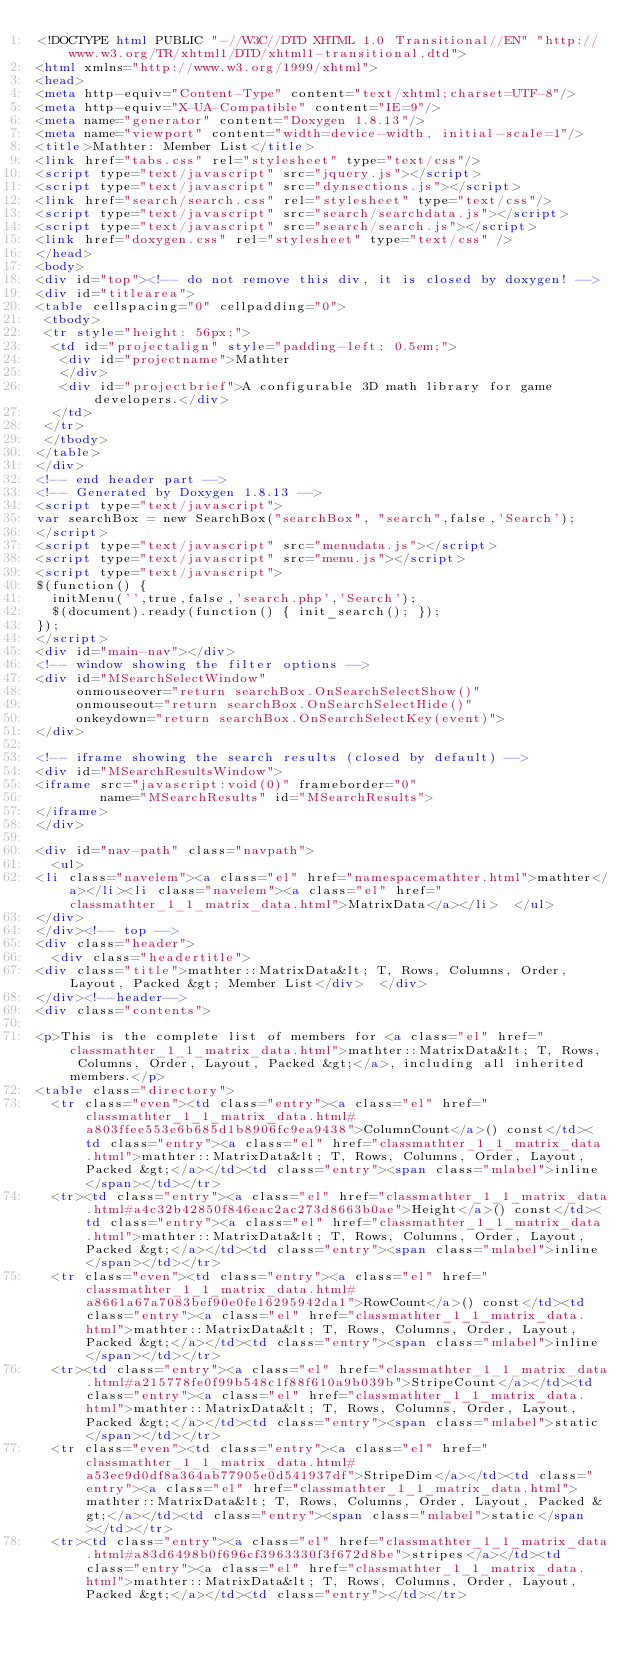<code> <loc_0><loc_0><loc_500><loc_500><_HTML_><!DOCTYPE html PUBLIC "-//W3C//DTD XHTML 1.0 Transitional//EN" "http://www.w3.org/TR/xhtml1/DTD/xhtml1-transitional.dtd">
<html xmlns="http://www.w3.org/1999/xhtml">
<head>
<meta http-equiv="Content-Type" content="text/xhtml;charset=UTF-8"/>
<meta http-equiv="X-UA-Compatible" content="IE=9"/>
<meta name="generator" content="Doxygen 1.8.13"/>
<meta name="viewport" content="width=device-width, initial-scale=1"/>
<title>Mathter: Member List</title>
<link href="tabs.css" rel="stylesheet" type="text/css"/>
<script type="text/javascript" src="jquery.js"></script>
<script type="text/javascript" src="dynsections.js"></script>
<link href="search/search.css" rel="stylesheet" type="text/css"/>
<script type="text/javascript" src="search/searchdata.js"></script>
<script type="text/javascript" src="search/search.js"></script>
<link href="doxygen.css" rel="stylesheet" type="text/css" />
</head>
<body>
<div id="top"><!-- do not remove this div, it is closed by doxygen! -->
<div id="titlearea">
<table cellspacing="0" cellpadding="0">
 <tbody>
 <tr style="height: 56px;">
  <td id="projectalign" style="padding-left: 0.5em;">
   <div id="projectname">Mathter
   </div>
   <div id="projectbrief">A configurable 3D math library for game developers.</div>
  </td>
 </tr>
 </tbody>
</table>
</div>
<!-- end header part -->
<!-- Generated by Doxygen 1.8.13 -->
<script type="text/javascript">
var searchBox = new SearchBox("searchBox", "search",false,'Search');
</script>
<script type="text/javascript" src="menudata.js"></script>
<script type="text/javascript" src="menu.js"></script>
<script type="text/javascript">
$(function() {
  initMenu('',true,false,'search.php','Search');
  $(document).ready(function() { init_search(); });
});
</script>
<div id="main-nav"></div>
<!-- window showing the filter options -->
<div id="MSearchSelectWindow"
     onmouseover="return searchBox.OnSearchSelectShow()"
     onmouseout="return searchBox.OnSearchSelectHide()"
     onkeydown="return searchBox.OnSearchSelectKey(event)">
</div>

<!-- iframe showing the search results (closed by default) -->
<div id="MSearchResultsWindow">
<iframe src="javascript:void(0)" frameborder="0" 
        name="MSearchResults" id="MSearchResults">
</iframe>
</div>

<div id="nav-path" class="navpath">
  <ul>
<li class="navelem"><a class="el" href="namespacemathter.html">mathter</a></li><li class="navelem"><a class="el" href="classmathter_1_1_matrix_data.html">MatrixData</a></li>  </ul>
</div>
</div><!-- top -->
<div class="header">
  <div class="headertitle">
<div class="title">mathter::MatrixData&lt; T, Rows, Columns, Order, Layout, Packed &gt; Member List</div>  </div>
</div><!--header-->
<div class="contents">

<p>This is the complete list of members for <a class="el" href="classmathter_1_1_matrix_data.html">mathter::MatrixData&lt; T, Rows, Columns, Order, Layout, Packed &gt;</a>, including all inherited members.</p>
<table class="directory">
  <tr class="even"><td class="entry"><a class="el" href="classmathter_1_1_matrix_data.html#a803ffee553e6b685d1b8906fc9ea9438">ColumnCount</a>() const</td><td class="entry"><a class="el" href="classmathter_1_1_matrix_data.html">mathter::MatrixData&lt; T, Rows, Columns, Order, Layout, Packed &gt;</a></td><td class="entry"><span class="mlabel">inline</span></td></tr>
  <tr><td class="entry"><a class="el" href="classmathter_1_1_matrix_data.html#a4c32b42850f846eac2ac273d8663b0ae">Height</a>() const</td><td class="entry"><a class="el" href="classmathter_1_1_matrix_data.html">mathter::MatrixData&lt; T, Rows, Columns, Order, Layout, Packed &gt;</a></td><td class="entry"><span class="mlabel">inline</span></td></tr>
  <tr class="even"><td class="entry"><a class="el" href="classmathter_1_1_matrix_data.html#a8661a67a7083bef90e0fe16295942da1">RowCount</a>() const</td><td class="entry"><a class="el" href="classmathter_1_1_matrix_data.html">mathter::MatrixData&lt; T, Rows, Columns, Order, Layout, Packed &gt;</a></td><td class="entry"><span class="mlabel">inline</span></td></tr>
  <tr><td class="entry"><a class="el" href="classmathter_1_1_matrix_data.html#a215778fe0f99b548c1f88f610a9b039b">StripeCount</a></td><td class="entry"><a class="el" href="classmathter_1_1_matrix_data.html">mathter::MatrixData&lt; T, Rows, Columns, Order, Layout, Packed &gt;</a></td><td class="entry"><span class="mlabel">static</span></td></tr>
  <tr class="even"><td class="entry"><a class="el" href="classmathter_1_1_matrix_data.html#a53ec9d0df8a364ab77905e0d541937df">StripeDim</a></td><td class="entry"><a class="el" href="classmathter_1_1_matrix_data.html">mathter::MatrixData&lt; T, Rows, Columns, Order, Layout, Packed &gt;</a></td><td class="entry"><span class="mlabel">static</span></td></tr>
  <tr><td class="entry"><a class="el" href="classmathter_1_1_matrix_data.html#a83d6498b0f696cf3963330f3f672d8be">stripes</a></td><td class="entry"><a class="el" href="classmathter_1_1_matrix_data.html">mathter::MatrixData&lt; T, Rows, Columns, Order, Layout, Packed &gt;</a></td><td class="entry"></td></tr></code> 